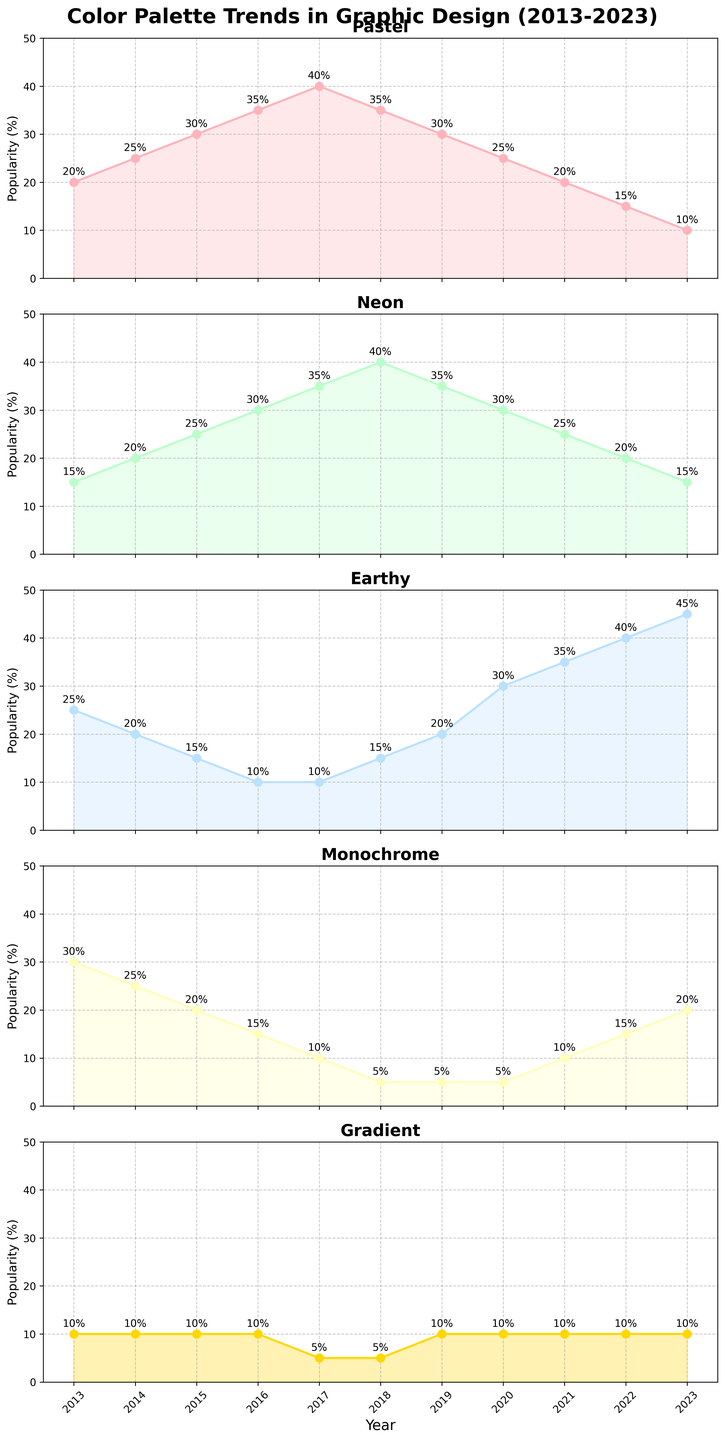What's the most popular color palette in 2023? To determine the most popular color palette in 2023, compare the values for each category. The highest value in 2023 is 45% for the Earthy palette.
Answer: Earthy Which color palette shows a consistent decline in popularity from 2013 to 2023? By observing the trends in each subplot, the Monochrome palette consistently declines from 30% in 2013 to 20% in 2023.
Answer: Monochrome How did the popularity of the pastel palette change from 2013 to 2017? Look at the values for the pastel palette from 2013 (20%) to 2017 (40%). The popularity increased by 20%.
Answer: Increased by 20% Compare the popularity of the Neon and Gradient palettes in 2016. Which one is more popular and by how much? In 2016, the popularity of Neon is 30% while that of Gradient is 10%. The Neon palette is more popular by 20%.
Answer: Neon by 20% Which color palette experienced the largest increase in popularity between 2019 and 2020? In 2019, Earthy had 20%, and in 2020, it increased to 30%. That's a 10% increase, which is the largest change between these years.
Answer: Earthy Between 2014 and 2017, did the pastel palette's popularity increase more significantly in a single year compared to the neon palette? From 2014 to 2015, pastel increased by 5%, and from 2015 to 2016, it increased by 5%. For neon, the increase was 5% annually from 2014 to 2017. The increases are similar at 5% annually.
Answer: No, both increased similarly What is the average popularity of the Gradient palette over the years shown? Sum the yearly values of the Gradient palette (10+10+10+10+5+5+10+10+10+10+10 = 100) and divide by the number of years (11). The average is 100/11 ≈ 9.1%.
Answer: 9.1% In which year did Earthy palettes become more popular than Neon palettes for the first time? By comparing the values yearly, Earthy surpassed Neon in popularity in 2020 with Earthy at 30% and Neon at 25%.
Answer: 2020 How did the Neon palette's popularity change between 2013 and 2018? In 2013, the Neon palette was at 15%, and it increased to 40% in 2018. This is a rise of 25%.
Answer: Increased by 25% Identify the year with the largest decline in popularity for the Monochrome palette. What was the percentage drop? From 2016 (15%) to 2017 (10%), the Monochrome palette saw the largest single-year decline, by 5%.
Answer: 2017, 5% decline 